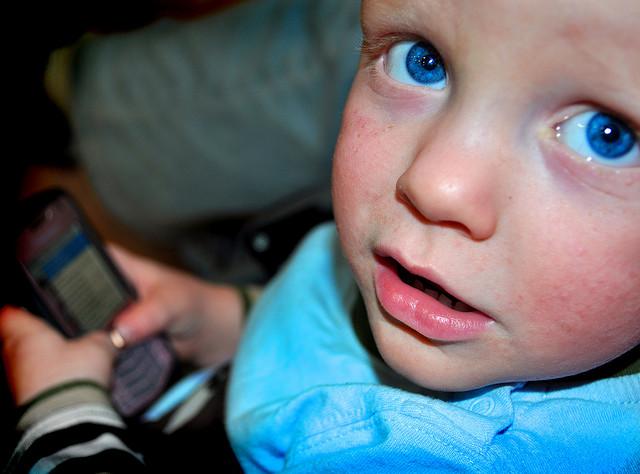Does the shirt enhance the color of the eyes?
Answer briefly. Yes. What is the kid holding?
Quick response, please. Phone. Does the boy look sleepy?
Be succinct. No. How old is the kid?
Answer briefly. 2. What color is the baby's shirt?
Short answer required. Blue. 